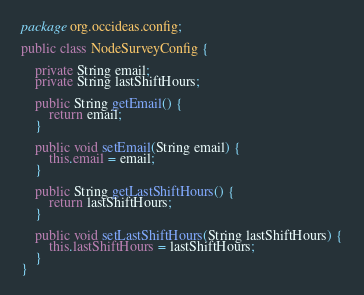<code> <loc_0><loc_0><loc_500><loc_500><_Java_>package org.occideas.config;

public class NodeSurveyConfig {

    private String email;
    private String lastShiftHours;

    public String getEmail() {
        return email;
    }

    public void setEmail(String email) {
        this.email = email;
    }

    public String getLastShiftHours() {
        return lastShiftHours;
    }

    public void setLastShiftHours(String lastShiftHours) {
        this.lastShiftHours = lastShiftHours;
    }
}
</code> 